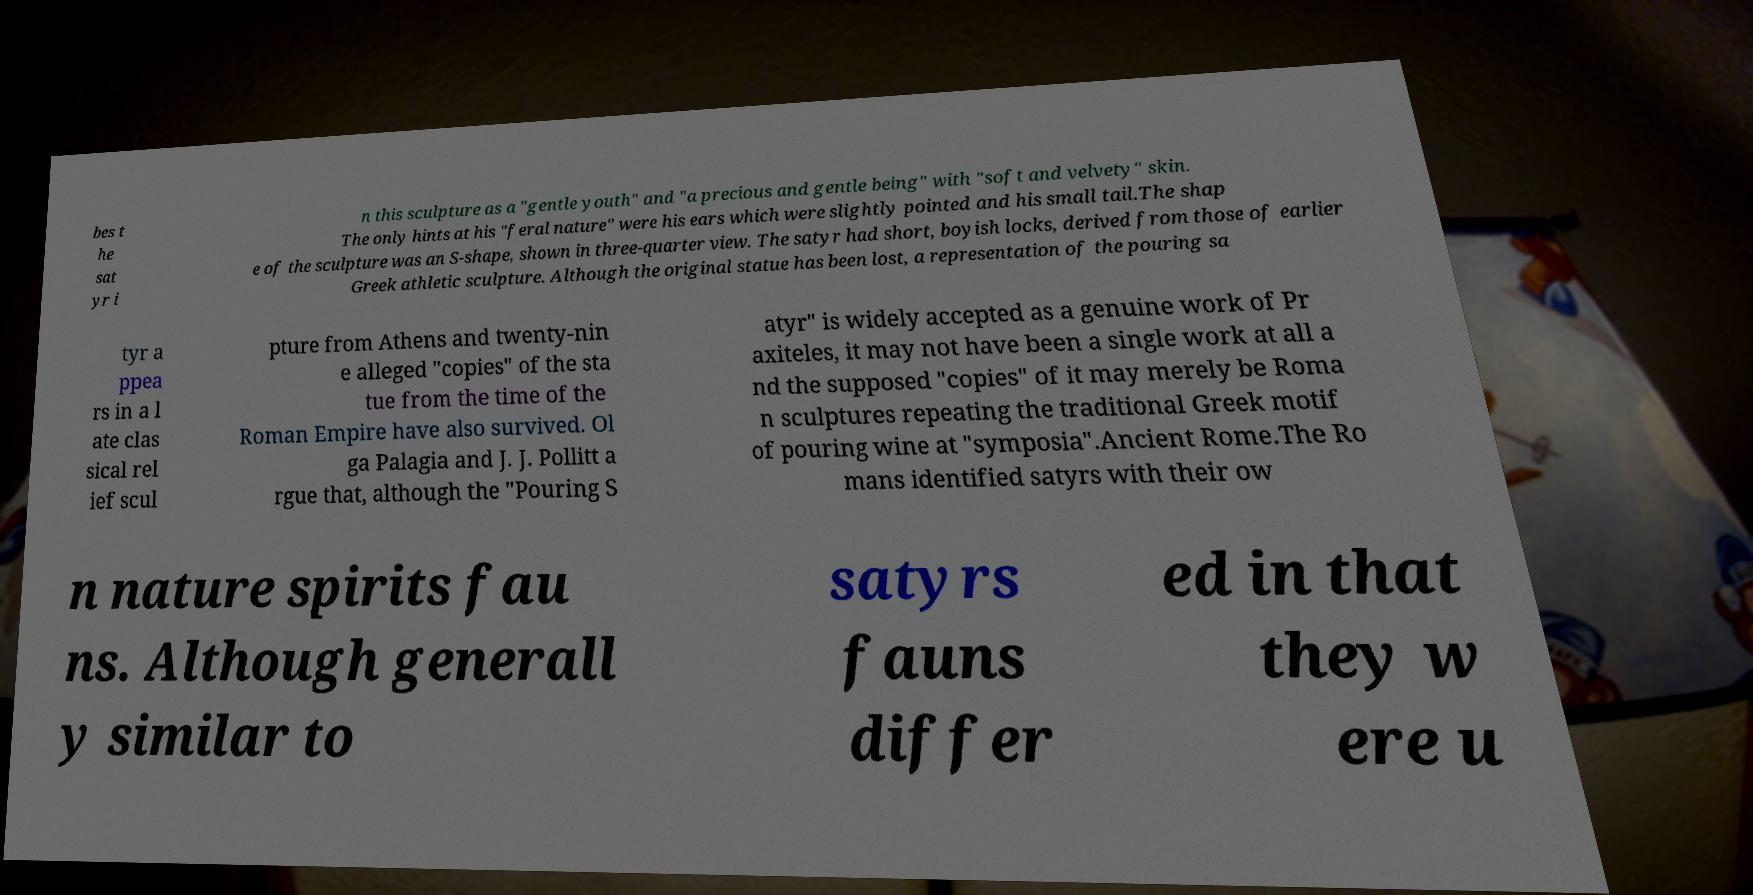Could you extract and type out the text from this image? bes t he sat yr i n this sculpture as a "gentle youth" and "a precious and gentle being" with "soft and velvety" skin. The only hints at his "feral nature" were his ears which were slightly pointed and his small tail.The shap e of the sculpture was an S-shape, shown in three-quarter view. The satyr had short, boyish locks, derived from those of earlier Greek athletic sculpture. Although the original statue has been lost, a representation of the pouring sa tyr a ppea rs in a l ate clas sical rel ief scul pture from Athens and twenty-nin e alleged "copies" of the sta tue from the time of the Roman Empire have also survived. Ol ga Palagia and J. J. Pollitt a rgue that, although the "Pouring S atyr" is widely accepted as a genuine work of Pr axiteles, it may not have been a single work at all a nd the supposed "copies" of it may merely be Roma n sculptures repeating the traditional Greek motif of pouring wine at "symposia".Ancient Rome.The Ro mans identified satyrs with their ow n nature spirits fau ns. Although generall y similar to satyrs fauns differ ed in that they w ere u 